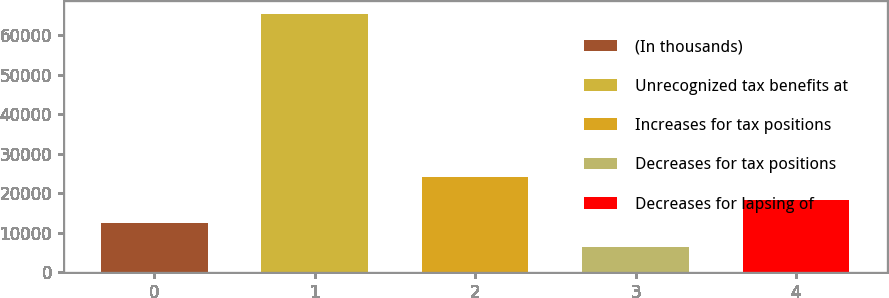<chart> <loc_0><loc_0><loc_500><loc_500><bar_chart><fcel>(In thousands)<fcel>Unrecognized tax benefits at<fcel>Increases for tax positions<fcel>Decreases for tax positions<fcel>Decreases for lapsing of<nl><fcel>12355.8<fcel>65396.4<fcel>24160.6<fcel>6453.4<fcel>18258.2<nl></chart> 